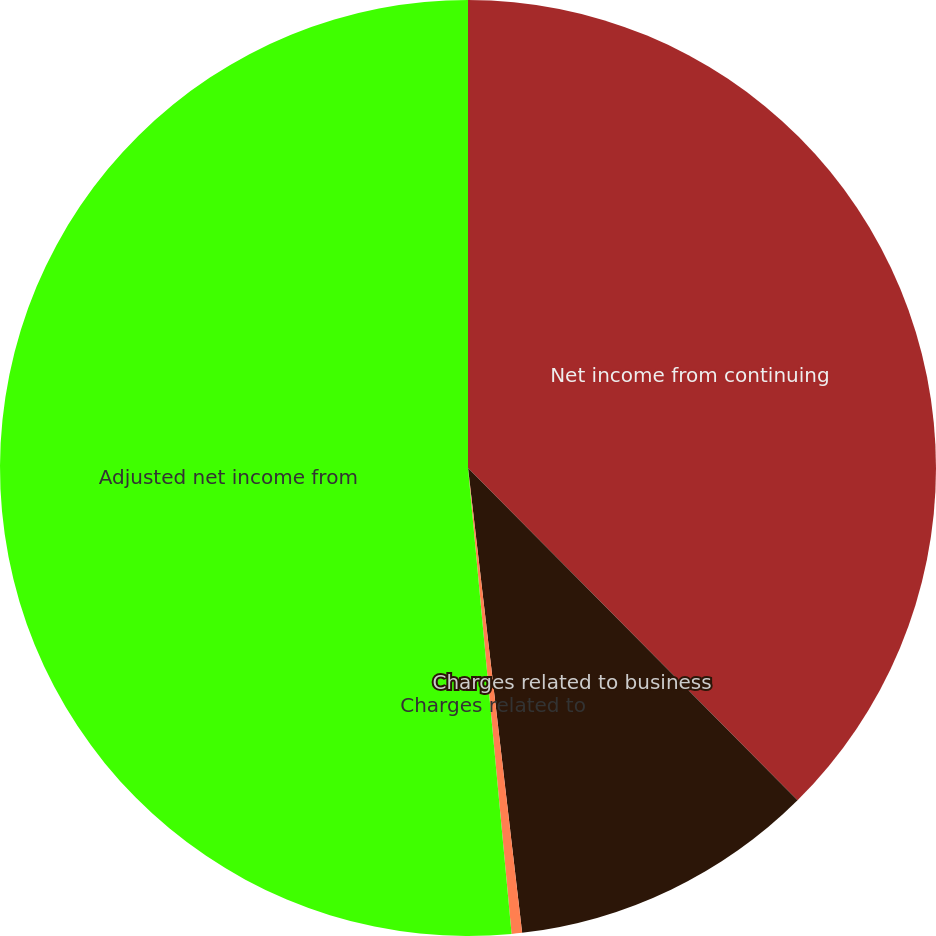Convert chart to OTSL. <chart><loc_0><loc_0><loc_500><loc_500><pie_chart><fcel>Net income from continuing<fcel>Charges related to business<fcel>Charges related to<fcel>Adjusted net income from<nl><fcel>37.57%<fcel>10.59%<fcel>0.36%<fcel>51.49%<nl></chart> 